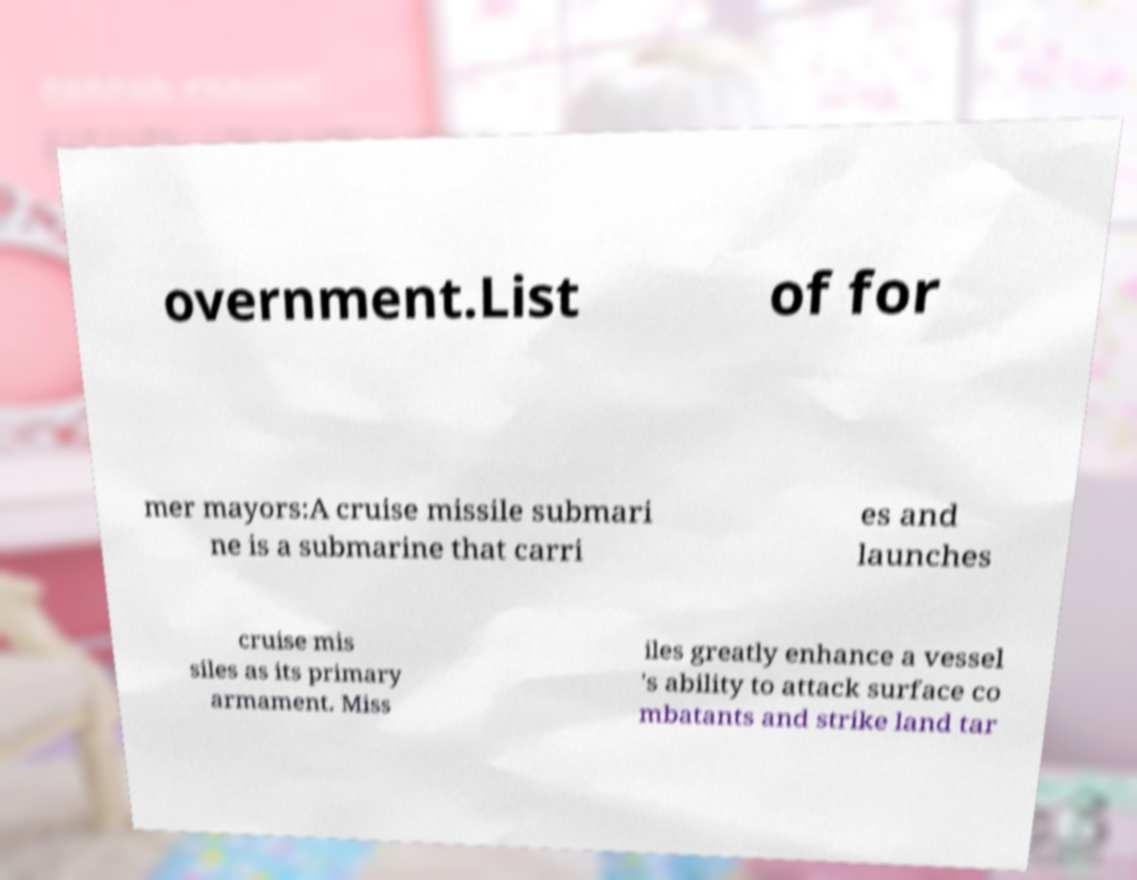Please identify and transcribe the text found in this image. overnment.List of for mer mayors:A cruise missile submari ne is a submarine that carri es and launches cruise mis siles as its primary armament. Miss iles greatly enhance a vessel 's ability to attack surface co mbatants and strike land tar 